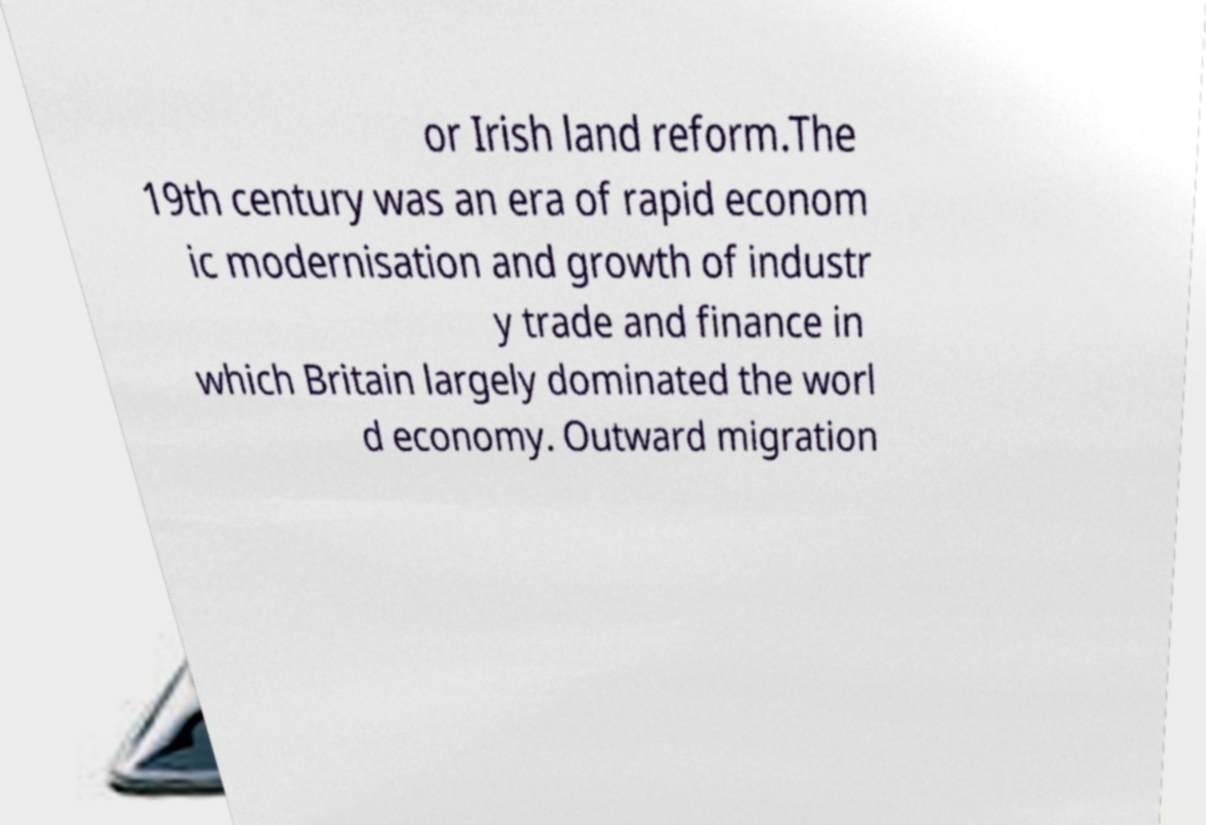Please identify and transcribe the text found in this image. or Irish land reform.The 19th century was an era of rapid econom ic modernisation and growth of industr y trade and finance in which Britain largely dominated the worl d economy. Outward migration 